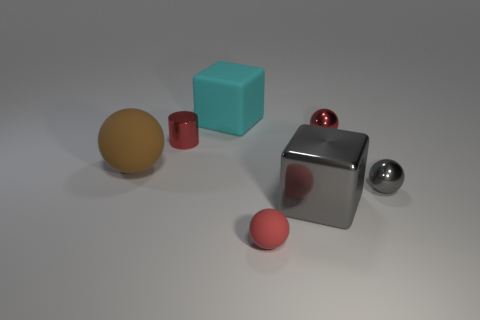Subtract all purple cylinders. How many red spheres are left? 2 Subtract 2 balls. How many balls are left? 2 Subtract all small matte balls. How many balls are left? 3 Subtract all brown balls. How many balls are left? 3 Add 1 big green rubber balls. How many objects exist? 8 Subtract all balls. How many objects are left? 3 Subtract all yellow spheres. Subtract all yellow cylinders. How many spheres are left? 4 Add 7 gray rubber cylinders. How many gray rubber cylinders exist? 7 Subtract 1 gray cubes. How many objects are left? 6 Subtract all big rubber objects. Subtract all blocks. How many objects are left? 3 